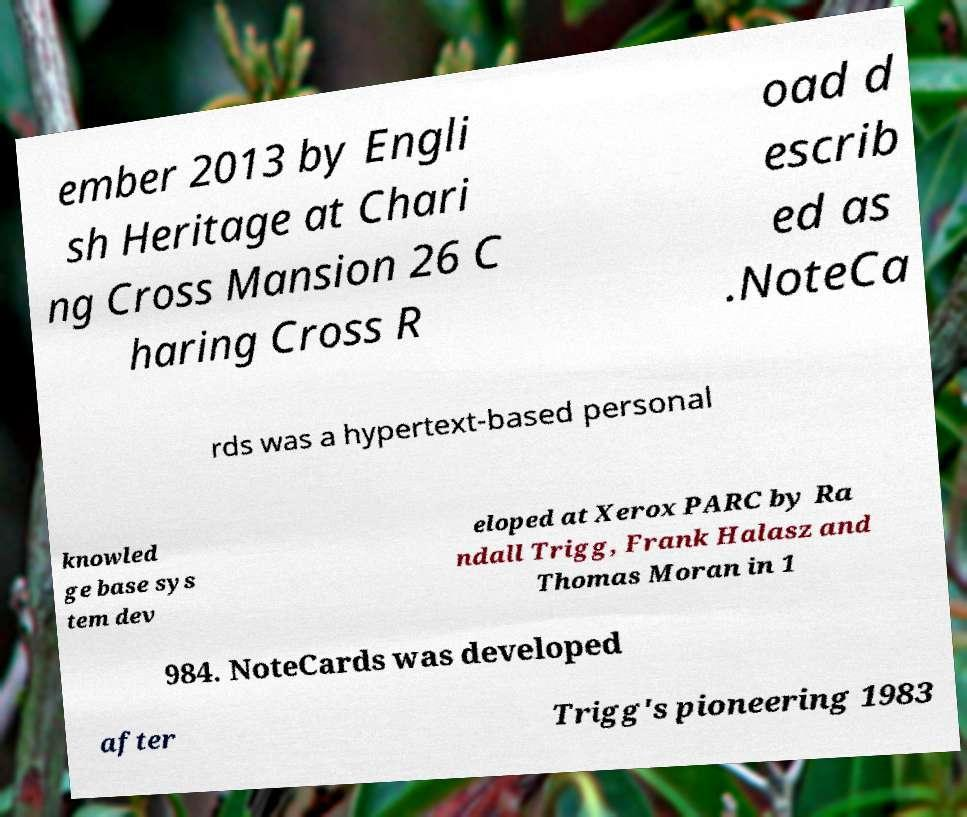Can you read and provide the text displayed in the image?This photo seems to have some interesting text. Can you extract and type it out for me? ember 2013 by Engli sh Heritage at Chari ng Cross Mansion 26 C haring Cross R oad d escrib ed as .NoteCa rds was a hypertext-based personal knowled ge base sys tem dev eloped at Xerox PARC by Ra ndall Trigg, Frank Halasz and Thomas Moran in 1 984. NoteCards was developed after Trigg's pioneering 1983 